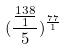<formula> <loc_0><loc_0><loc_500><loc_500>( \frac { \frac { 1 3 8 } { 1 } } { 5 } ) ^ { \frac { 7 7 } { 1 } }</formula> 